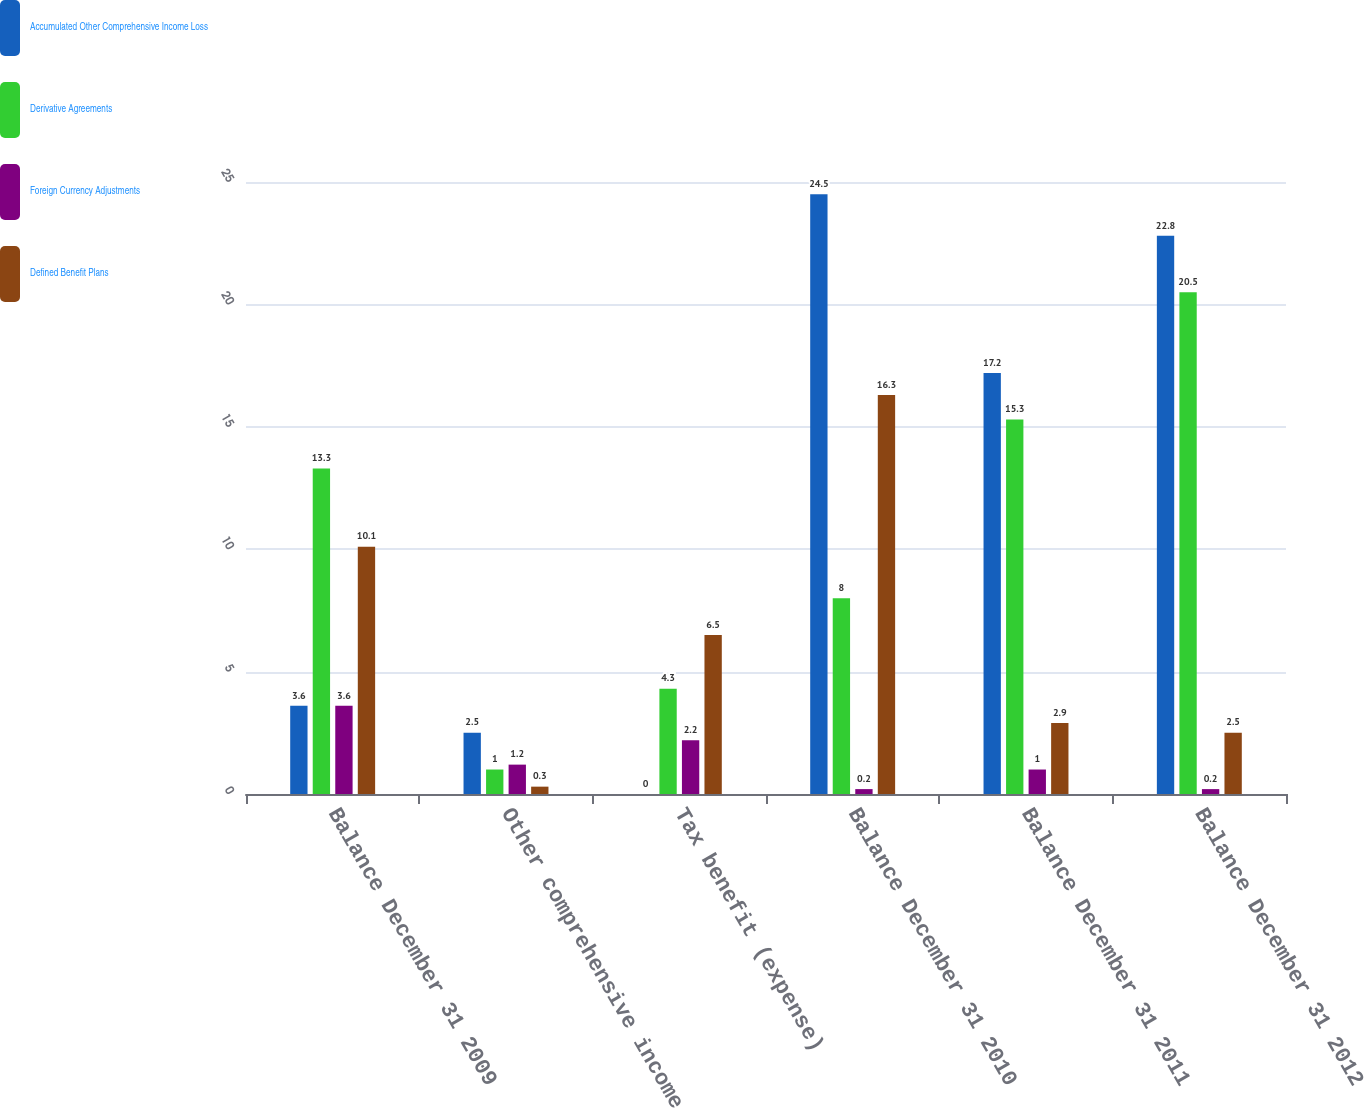Convert chart. <chart><loc_0><loc_0><loc_500><loc_500><stacked_bar_chart><ecel><fcel>Balance December 31 2009<fcel>Other comprehensive income<fcel>Tax benefit (expense)<fcel>Balance December 31 2010<fcel>Balance December 31 2011<fcel>Balance December 31 2012<nl><fcel>Accumulated Other Comprehensive Income Loss<fcel>3.6<fcel>2.5<fcel>0<fcel>24.5<fcel>17.2<fcel>22.8<nl><fcel>Derivative Agreements<fcel>13.3<fcel>1<fcel>4.3<fcel>8<fcel>15.3<fcel>20.5<nl><fcel>Foreign Currency Adjustments<fcel>3.6<fcel>1.2<fcel>2.2<fcel>0.2<fcel>1<fcel>0.2<nl><fcel>Defined Benefit Plans<fcel>10.1<fcel>0.3<fcel>6.5<fcel>16.3<fcel>2.9<fcel>2.5<nl></chart> 